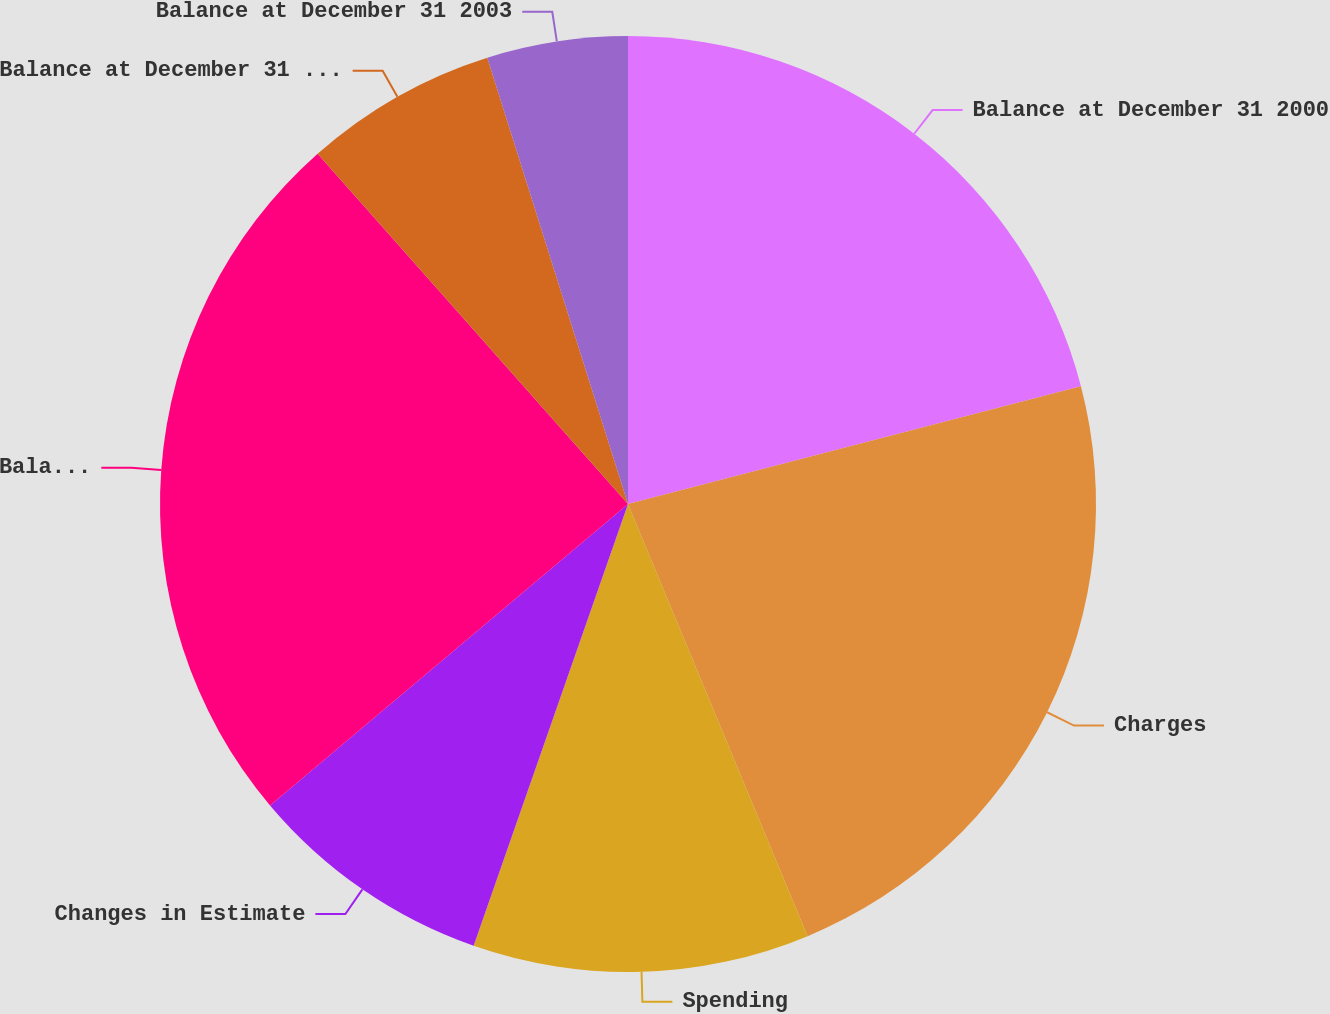Convert chart. <chart><loc_0><loc_0><loc_500><loc_500><pie_chart><fcel>Balance at December 31 2000<fcel>Charges<fcel>Spending<fcel>Changes in Estimate<fcel>Balance at December 31 2001<fcel>Balance at December 31 2002<fcel>Balance at December 31 2003<nl><fcel>20.95%<fcel>22.78%<fcel>11.62%<fcel>8.51%<fcel>24.6%<fcel>6.68%<fcel>4.86%<nl></chart> 